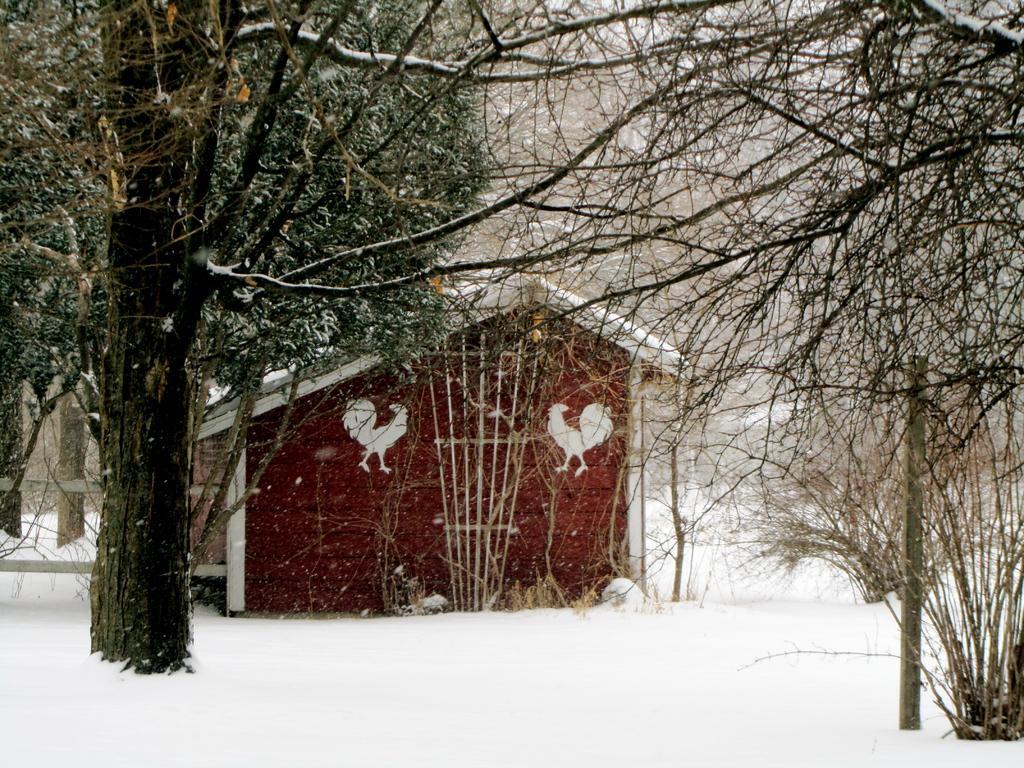How would you summarize this image in a sentence or two? In this picture, we can see the ground with snow, we can see house, and trees. 